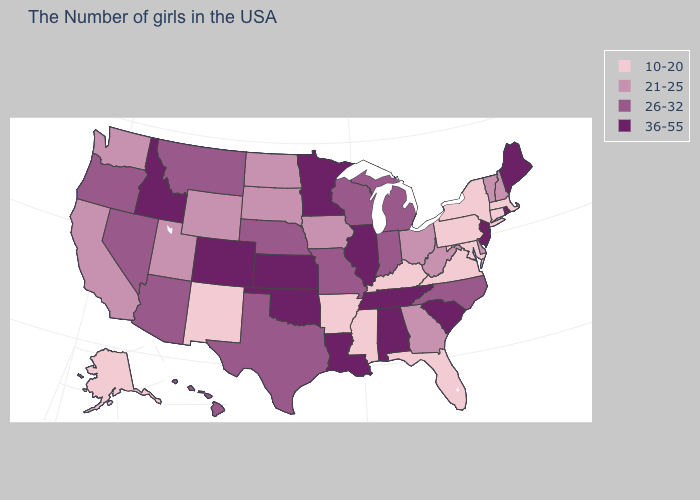Does New York have the lowest value in the USA?
Answer briefly. Yes. Which states have the highest value in the USA?
Be succinct. Maine, Rhode Island, New Jersey, South Carolina, Alabama, Tennessee, Illinois, Louisiana, Minnesota, Kansas, Oklahoma, Colorado, Idaho. What is the value of Nevada?
Concise answer only. 26-32. Name the states that have a value in the range 21-25?
Be succinct. New Hampshire, Vermont, Delaware, West Virginia, Ohio, Georgia, Iowa, South Dakota, North Dakota, Wyoming, Utah, California, Washington. Does Missouri have a higher value than Arkansas?
Quick response, please. Yes. Name the states that have a value in the range 36-55?
Give a very brief answer. Maine, Rhode Island, New Jersey, South Carolina, Alabama, Tennessee, Illinois, Louisiana, Minnesota, Kansas, Oklahoma, Colorado, Idaho. Name the states that have a value in the range 10-20?
Be succinct. Massachusetts, Connecticut, New York, Maryland, Pennsylvania, Virginia, Florida, Kentucky, Mississippi, Arkansas, New Mexico, Alaska. What is the value of Montana?
Give a very brief answer. 26-32. What is the highest value in states that border Minnesota?
Quick response, please. 26-32. Name the states that have a value in the range 36-55?
Answer briefly. Maine, Rhode Island, New Jersey, South Carolina, Alabama, Tennessee, Illinois, Louisiana, Minnesota, Kansas, Oklahoma, Colorado, Idaho. Does Rhode Island have the highest value in the USA?
Be succinct. Yes. Which states have the lowest value in the USA?
Keep it brief. Massachusetts, Connecticut, New York, Maryland, Pennsylvania, Virginia, Florida, Kentucky, Mississippi, Arkansas, New Mexico, Alaska. How many symbols are there in the legend?
Quick response, please. 4. How many symbols are there in the legend?
Keep it brief. 4. Name the states that have a value in the range 36-55?
Answer briefly. Maine, Rhode Island, New Jersey, South Carolina, Alabama, Tennessee, Illinois, Louisiana, Minnesota, Kansas, Oklahoma, Colorado, Idaho. 